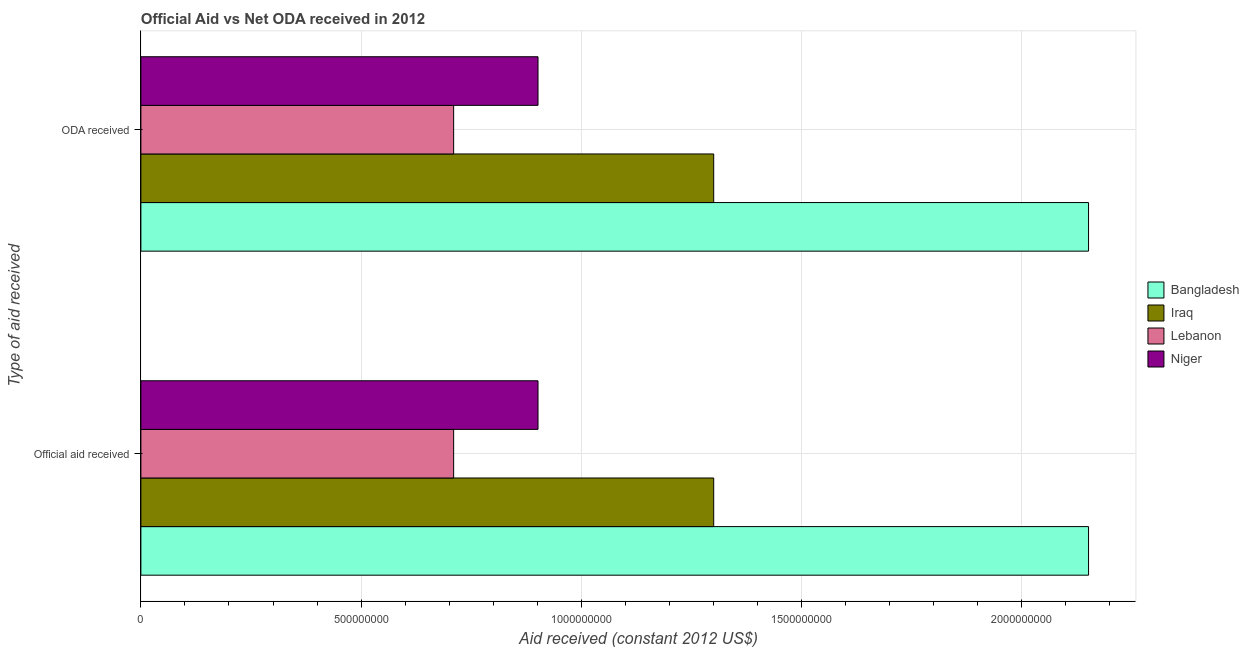How many different coloured bars are there?
Your answer should be very brief. 4. How many groups of bars are there?
Keep it short and to the point. 2. What is the label of the 1st group of bars from the top?
Give a very brief answer. ODA received. What is the official aid received in Lebanon?
Ensure brevity in your answer.  7.10e+08. Across all countries, what is the maximum oda received?
Keep it short and to the point. 2.15e+09. Across all countries, what is the minimum official aid received?
Provide a succinct answer. 7.10e+08. In which country was the official aid received minimum?
Offer a terse response. Lebanon. What is the total official aid received in the graph?
Your answer should be very brief. 5.07e+09. What is the difference between the official aid received in Niger and that in Bangladesh?
Make the answer very short. -1.25e+09. What is the difference between the official aid received in Iraq and the oda received in Niger?
Give a very brief answer. 3.99e+08. What is the average official aid received per country?
Make the answer very short. 1.27e+09. What is the ratio of the official aid received in Bangladesh to that in Niger?
Provide a succinct answer. 2.39. Is the oda received in Lebanon less than that in Iraq?
Give a very brief answer. Yes. In how many countries, is the oda received greater than the average oda received taken over all countries?
Offer a very short reply. 2. What does the 4th bar from the top in ODA received represents?
Make the answer very short. Bangladesh. What does the 4th bar from the bottom in ODA received represents?
Your response must be concise. Niger. How many bars are there?
Give a very brief answer. 8. Are all the bars in the graph horizontal?
Provide a short and direct response. Yes. What is the difference between two consecutive major ticks on the X-axis?
Provide a succinct answer. 5.00e+08. Where does the legend appear in the graph?
Give a very brief answer. Center right. How are the legend labels stacked?
Provide a succinct answer. Vertical. What is the title of the graph?
Provide a succinct answer. Official Aid vs Net ODA received in 2012 . What is the label or title of the X-axis?
Give a very brief answer. Aid received (constant 2012 US$). What is the label or title of the Y-axis?
Make the answer very short. Type of aid received. What is the Aid received (constant 2012 US$) of Bangladesh in Official aid received?
Offer a very short reply. 2.15e+09. What is the Aid received (constant 2012 US$) of Iraq in Official aid received?
Your answer should be compact. 1.30e+09. What is the Aid received (constant 2012 US$) of Lebanon in Official aid received?
Your response must be concise. 7.10e+08. What is the Aid received (constant 2012 US$) in Niger in Official aid received?
Provide a succinct answer. 9.02e+08. What is the Aid received (constant 2012 US$) of Bangladesh in ODA received?
Offer a very short reply. 2.15e+09. What is the Aid received (constant 2012 US$) of Iraq in ODA received?
Your response must be concise. 1.30e+09. What is the Aid received (constant 2012 US$) of Lebanon in ODA received?
Offer a very short reply. 7.10e+08. What is the Aid received (constant 2012 US$) of Niger in ODA received?
Your answer should be very brief. 9.02e+08. Across all Type of aid received, what is the maximum Aid received (constant 2012 US$) of Bangladesh?
Your answer should be compact. 2.15e+09. Across all Type of aid received, what is the maximum Aid received (constant 2012 US$) of Iraq?
Provide a succinct answer. 1.30e+09. Across all Type of aid received, what is the maximum Aid received (constant 2012 US$) of Lebanon?
Give a very brief answer. 7.10e+08. Across all Type of aid received, what is the maximum Aid received (constant 2012 US$) of Niger?
Provide a succinct answer. 9.02e+08. Across all Type of aid received, what is the minimum Aid received (constant 2012 US$) in Bangladesh?
Your response must be concise. 2.15e+09. Across all Type of aid received, what is the minimum Aid received (constant 2012 US$) in Iraq?
Your answer should be compact. 1.30e+09. Across all Type of aid received, what is the minimum Aid received (constant 2012 US$) of Lebanon?
Your answer should be very brief. 7.10e+08. Across all Type of aid received, what is the minimum Aid received (constant 2012 US$) of Niger?
Keep it short and to the point. 9.02e+08. What is the total Aid received (constant 2012 US$) of Bangladesh in the graph?
Ensure brevity in your answer.  4.30e+09. What is the total Aid received (constant 2012 US$) of Iraq in the graph?
Offer a very short reply. 2.60e+09. What is the total Aid received (constant 2012 US$) of Lebanon in the graph?
Offer a terse response. 1.42e+09. What is the total Aid received (constant 2012 US$) in Niger in the graph?
Your answer should be compact. 1.80e+09. What is the difference between the Aid received (constant 2012 US$) in Iraq in Official aid received and that in ODA received?
Offer a very short reply. 0. What is the difference between the Aid received (constant 2012 US$) in Lebanon in Official aid received and that in ODA received?
Give a very brief answer. 0. What is the difference between the Aid received (constant 2012 US$) in Niger in Official aid received and that in ODA received?
Provide a short and direct response. 0. What is the difference between the Aid received (constant 2012 US$) in Bangladesh in Official aid received and the Aid received (constant 2012 US$) in Iraq in ODA received?
Give a very brief answer. 8.51e+08. What is the difference between the Aid received (constant 2012 US$) of Bangladesh in Official aid received and the Aid received (constant 2012 US$) of Lebanon in ODA received?
Make the answer very short. 1.44e+09. What is the difference between the Aid received (constant 2012 US$) in Bangladesh in Official aid received and the Aid received (constant 2012 US$) in Niger in ODA received?
Your answer should be very brief. 1.25e+09. What is the difference between the Aid received (constant 2012 US$) of Iraq in Official aid received and the Aid received (constant 2012 US$) of Lebanon in ODA received?
Your response must be concise. 5.91e+08. What is the difference between the Aid received (constant 2012 US$) of Iraq in Official aid received and the Aid received (constant 2012 US$) of Niger in ODA received?
Make the answer very short. 3.99e+08. What is the difference between the Aid received (constant 2012 US$) of Lebanon in Official aid received and the Aid received (constant 2012 US$) of Niger in ODA received?
Your response must be concise. -1.92e+08. What is the average Aid received (constant 2012 US$) of Bangladesh per Type of aid received?
Give a very brief answer. 2.15e+09. What is the average Aid received (constant 2012 US$) in Iraq per Type of aid received?
Give a very brief answer. 1.30e+09. What is the average Aid received (constant 2012 US$) in Lebanon per Type of aid received?
Provide a short and direct response. 7.10e+08. What is the average Aid received (constant 2012 US$) of Niger per Type of aid received?
Provide a succinct answer. 9.02e+08. What is the difference between the Aid received (constant 2012 US$) of Bangladesh and Aid received (constant 2012 US$) of Iraq in Official aid received?
Make the answer very short. 8.51e+08. What is the difference between the Aid received (constant 2012 US$) of Bangladesh and Aid received (constant 2012 US$) of Lebanon in Official aid received?
Provide a succinct answer. 1.44e+09. What is the difference between the Aid received (constant 2012 US$) in Bangladesh and Aid received (constant 2012 US$) in Niger in Official aid received?
Offer a very short reply. 1.25e+09. What is the difference between the Aid received (constant 2012 US$) of Iraq and Aid received (constant 2012 US$) of Lebanon in Official aid received?
Offer a very short reply. 5.91e+08. What is the difference between the Aid received (constant 2012 US$) of Iraq and Aid received (constant 2012 US$) of Niger in Official aid received?
Offer a terse response. 3.99e+08. What is the difference between the Aid received (constant 2012 US$) in Lebanon and Aid received (constant 2012 US$) in Niger in Official aid received?
Offer a very short reply. -1.92e+08. What is the difference between the Aid received (constant 2012 US$) of Bangladesh and Aid received (constant 2012 US$) of Iraq in ODA received?
Your answer should be very brief. 8.51e+08. What is the difference between the Aid received (constant 2012 US$) in Bangladesh and Aid received (constant 2012 US$) in Lebanon in ODA received?
Offer a very short reply. 1.44e+09. What is the difference between the Aid received (constant 2012 US$) in Bangladesh and Aid received (constant 2012 US$) in Niger in ODA received?
Provide a short and direct response. 1.25e+09. What is the difference between the Aid received (constant 2012 US$) in Iraq and Aid received (constant 2012 US$) in Lebanon in ODA received?
Offer a terse response. 5.91e+08. What is the difference between the Aid received (constant 2012 US$) of Iraq and Aid received (constant 2012 US$) of Niger in ODA received?
Your response must be concise. 3.99e+08. What is the difference between the Aid received (constant 2012 US$) in Lebanon and Aid received (constant 2012 US$) in Niger in ODA received?
Offer a very short reply. -1.92e+08. What is the ratio of the Aid received (constant 2012 US$) in Bangladesh in Official aid received to that in ODA received?
Your answer should be very brief. 1. What is the ratio of the Aid received (constant 2012 US$) of Lebanon in Official aid received to that in ODA received?
Keep it short and to the point. 1. What is the ratio of the Aid received (constant 2012 US$) in Niger in Official aid received to that in ODA received?
Make the answer very short. 1. What is the difference between the highest and the lowest Aid received (constant 2012 US$) in Lebanon?
Give a very brief answer. 0. What is the difference between the highest and the lowest Aid received (constant 2012 US$) in Niger?
Your answer should be very brief. 0. 